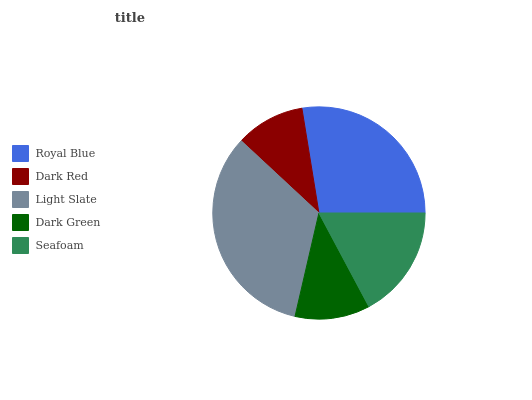Is Dark Red the minimum?
Answer yes or no. Yes. Is Light Slate the maximum?
Answer yes or no. Yes. Is Light Slate the minimum?
Answer yes or no. No. Is Dark Red the maximum?
Answer yes or no. No. Is Light Slate greater than Dark Red?
Answer yes or no. Yes. Is Dark Red less than Light Slate?
Answer yes or no. Yes. Is Dark Red greater than Light Slate?
Answer yes or no. No. Is Light Slate less than Dark Red?
Answer yes or no. No. Is Seafoam the high median?
Answer yes or no. Yes. Is Seafoam the low median?
Answer yes or no. Yes. Is Royal Blue the high median?
Answer yes or no. No. Is Royal Blue the low median?
Answer yes or no. No. 